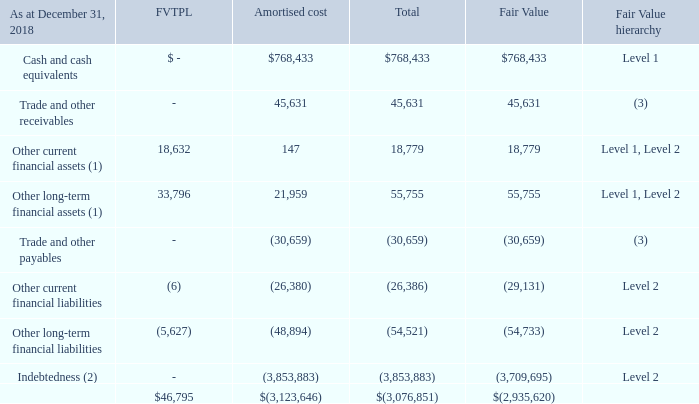28. FINANCIAL INSTRUMENTS (cont.)
(1) Other current and long-term financial assets classified as fair value through profit or loss were calculated using level 2 of the fair value hierarchy. All other balances were calculated using level 1 of the fair value hierarchy. (1) Other current and long-term financial assets classified as fair value through profit or loss were calculated using level 2 of the fair value hierarchy. All other balances were calculated using level 1 of the fair value hierarchy.
(2) Indebtedness excludes deferred financing costs and prepayment options (December 31, 2018 – deferred financing costs, interest rate floor, prepayment option and net gain on repricing/repayment). (2) Indebtedness excludes deferred financing costs and prepayment options (December 31, 2018 – deferred financing costs, interest rate floor, prepayment option and net gain on repricing/repayment).
(3) Trade and other receivables and trade and other payables approximate fair value due to the short-term maturity of these instruments.
What are the respective fair value hierarchies of cash and cash equivalents as well as other current financial liabilities? Level 1, level 2. What are the financial instruments classified under Level 1 under the fair value hierarchy? Cash and cash equivalents, other current financial assets, other long-term financial assets. What are the financial instruments that do not have a fair value hierarchy classification? Trade and other receivables, trade and other payables. What is the total fair value of financial instruments without a fair value hierarchy?
Answer scale should be: thousand. 45,631 + (-30,659) 
Answer: 14972. What is the value of the the company's cash and cash equivalents as a percentage of its total financial instruments?
Answer scale should be: percent. 768,433/(-3,076,851) 
Answer: -24.97. What is the difference between the FVTPL of the other current and long-term financial assets?
Answer scale should be: thousand. 33,796 - 18,632 
Answer: 15164. 